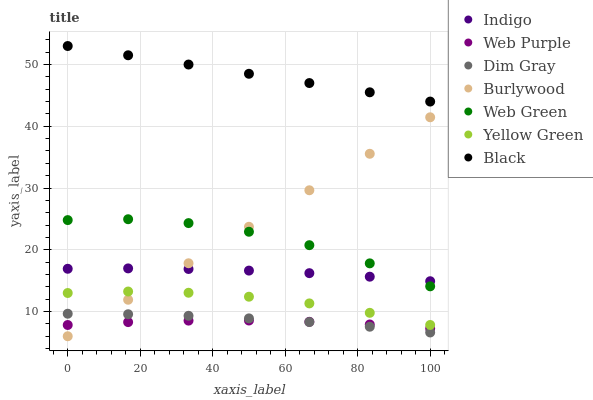Does Web Purple have the minimum area under the curve?
Answer yes or no. Yes. Does Black have the maximum area under the curve?
Answer yes or no. Yes. Does Indigo have the minimum area under the curve?
Answer yes or no. No. Does Indigo have the maximum area under the curve?
Answer yes or no. No. Is Burlywood the smoothest?
Answer yes or no. Yes. Is Web Green the roughest?
Answer yes or no. Yes. Is Indigo the smoothest?
Answer yes or no. No. Is Indigo the roughest?
Answer yes or no. No. Does Burlywood have the lowest value?
Answer yes or no. Yes. Does Indigo have the lowest value?
Answer yes or no. No. Does Black have the highest value?
Answer yes or no. Yes. Does Indigo have the highest value?
Answer yes or no. No. Is Web Purple less than Web Green?
Answer yes or no. Yes. Is Indigo greater than Dim Gray?
Answer yes or no. Yes. Does Indigo intersect Web Green?
Answer yes or no. Yes. Is Indigo less than Web Green?
Answer yes or no. No. Is Indigo greater than Web Green?
Answer yes or no. No. Does Web Purple intersect Web Green?
Answer yes or no. No. 